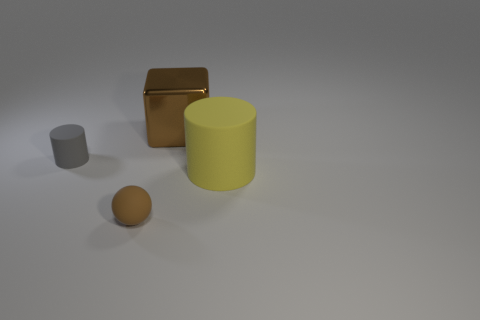Add 3 small cyan matte objects. How many objects exist? 7 Subtract all balls. How many objects are left? 3 Add 1 brown objects. How many brown objects exist? 3 Subtract 0 purple spheres. How many objects are left? 4 Subtract all small brown objects. Subtract all small gray rubber cylinders. How many objects are left? 2 Add 1 brown shiny things. How many brown shiny things are left? 2 